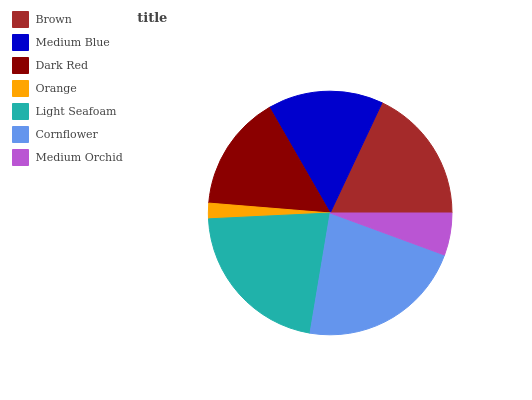Is Orange the minimum?
Answer yes or no. Yes. Is Cornflower the maximum?
Answer yes or no. Yes. Is Medium Blue the minimum?
Answer yes or no. No. Is Medium Blue the maximum?
Answer yes or no. No. Is Brown greater than Medium Blue?
Answer yes or no. Yes. Is Medium Blue less than Brown?
Answer yes or no. Yes. Is Medium Blue greater than Brown?
Answer yes or no. No. Is Brown less than Medium Blue?
Answer yes or no. No. Is Dark Red the high median?
Answer yes or no. Yes. Is Dark Red the low median?
Answer yes or no. Yes. Is Medium Blue the high median?
Answer yes or no. No. Is Brown the low median?
Answer yes or no. No. 